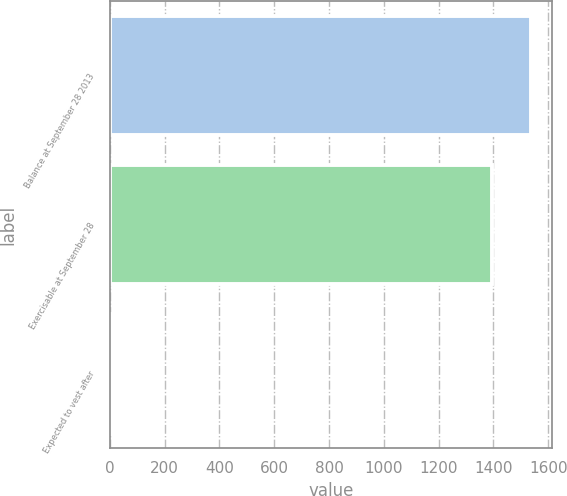Convert chart to OTSL. <chart><loc_0><loc_0><loc_500><loc_500><bar_chart><fcel>Balance at September 28 2013<fcel>Exercisable at September 28<fcel>Expected to vest after<nl><fcel>1535.6<fcel>1396<fcel>9<nl></chart> 